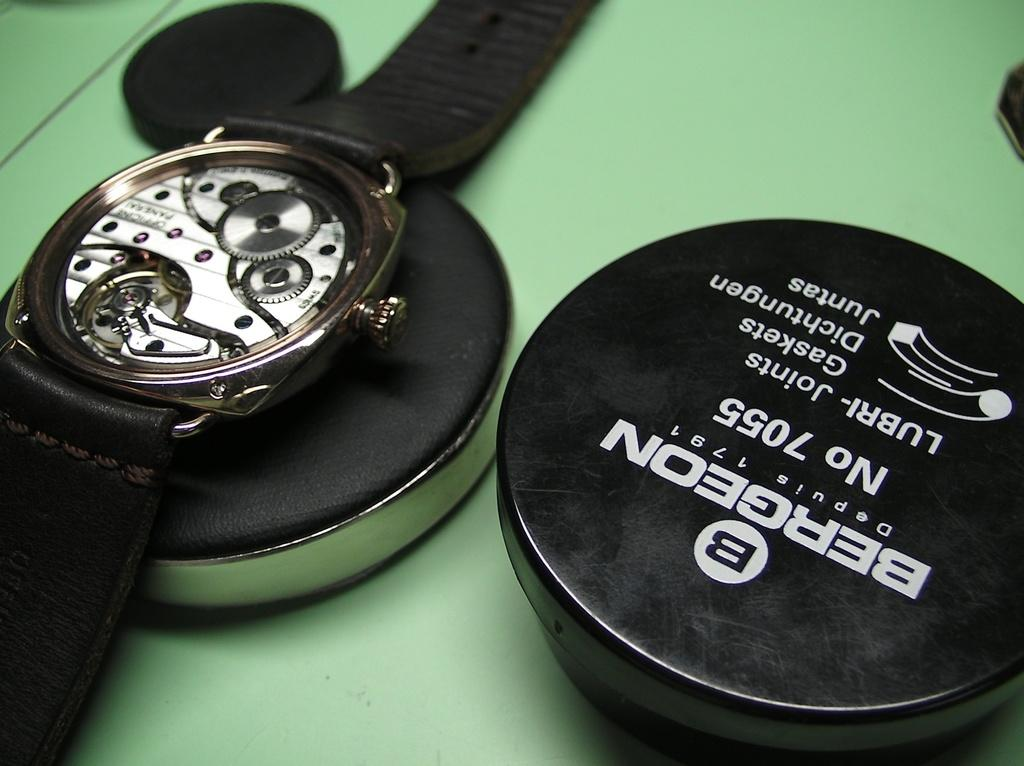<image>
Share a concise interpretation of the image provided. The back, inside of a watch is being displayed beside a black round informative disc with the watch's information on it. 